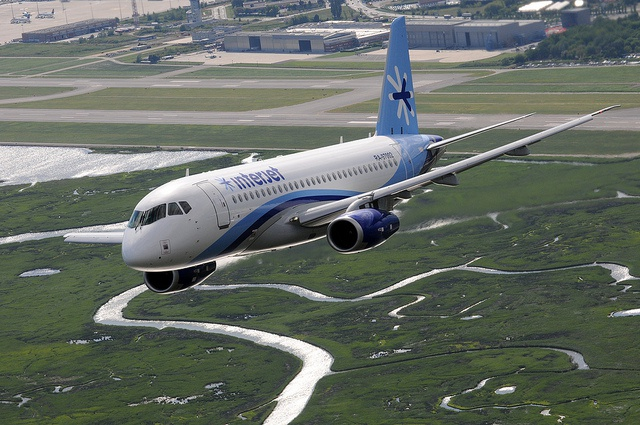Describe the objects in this image and their specific colors. I can see a airplane in lightgray, darkgray, black, and gray tones in this image. 